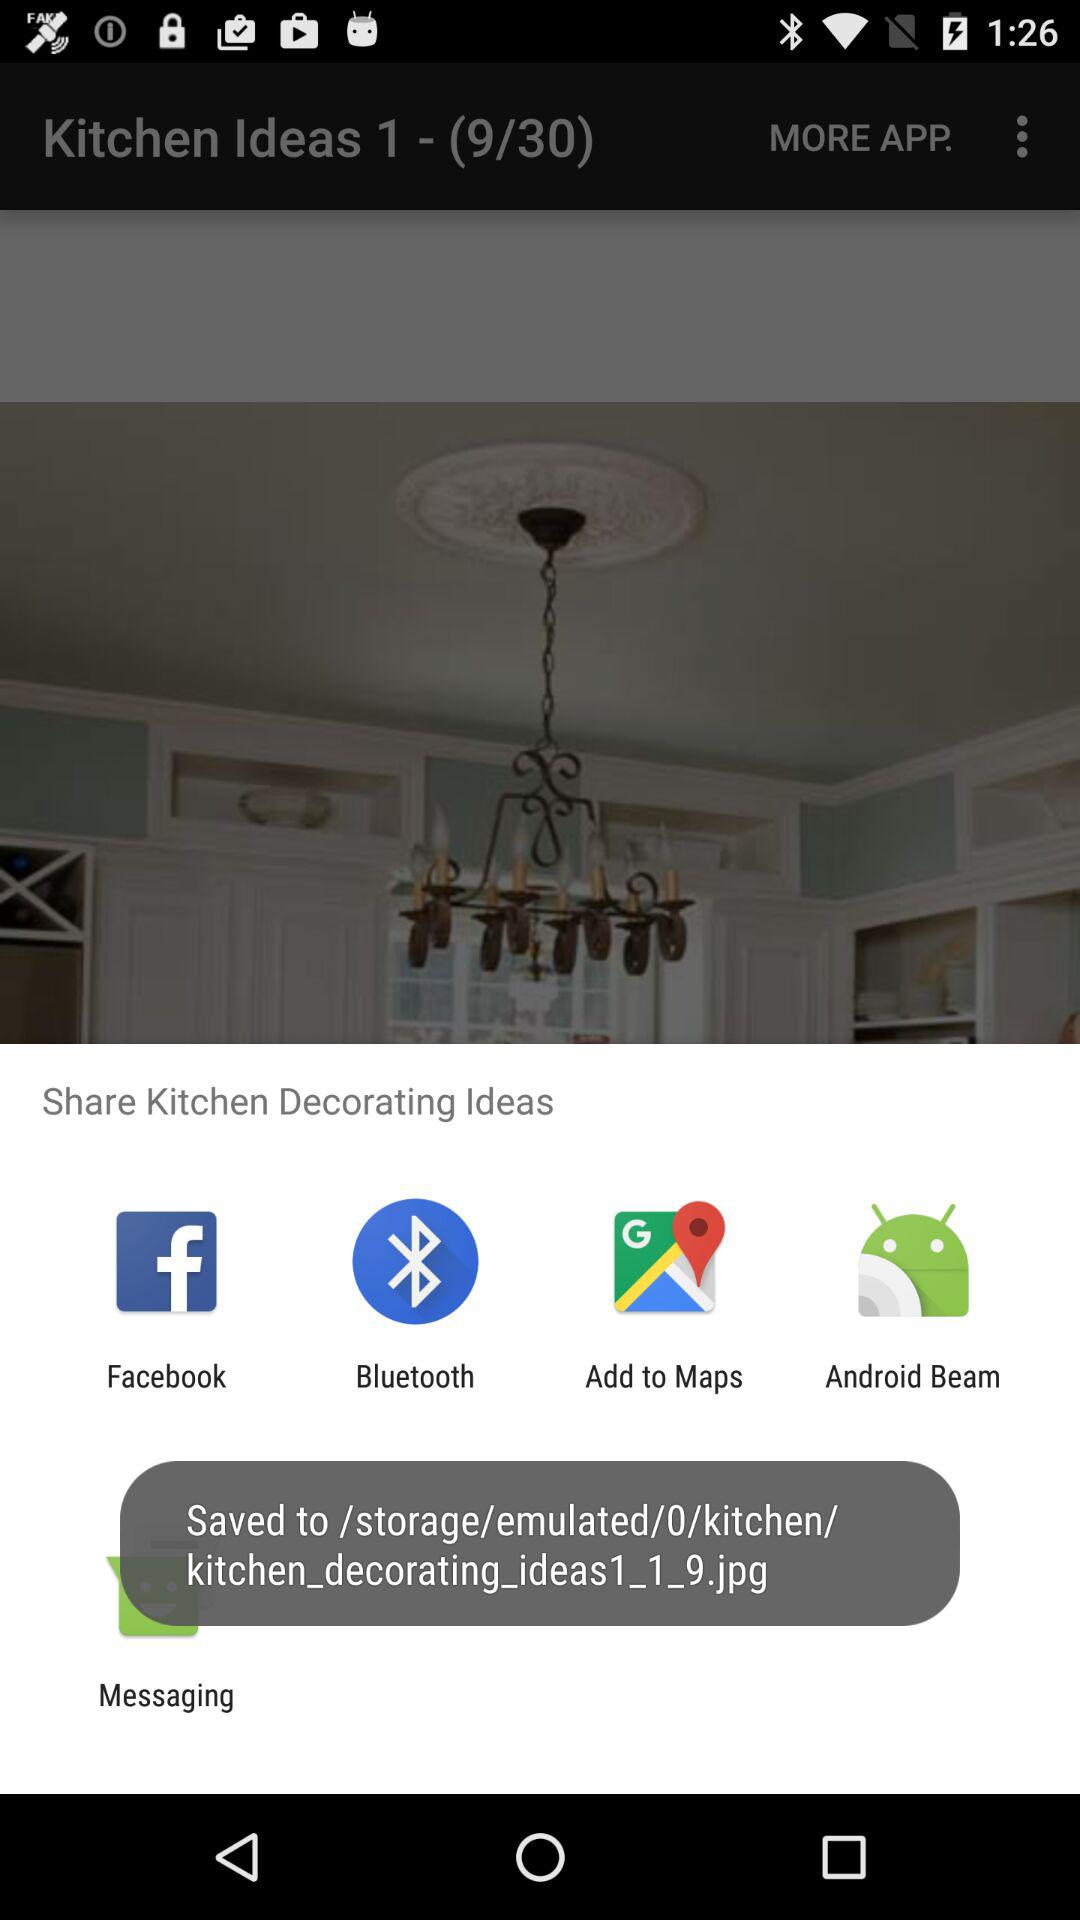Which applications can be used to share the "Kitchen Decorating Ideas"? The applications that can be used to share the "Kitchen Decorating Ideas" are "Facebook", "Bluetooth", "Add to Maps", "Android Beam" and "Messaging". 